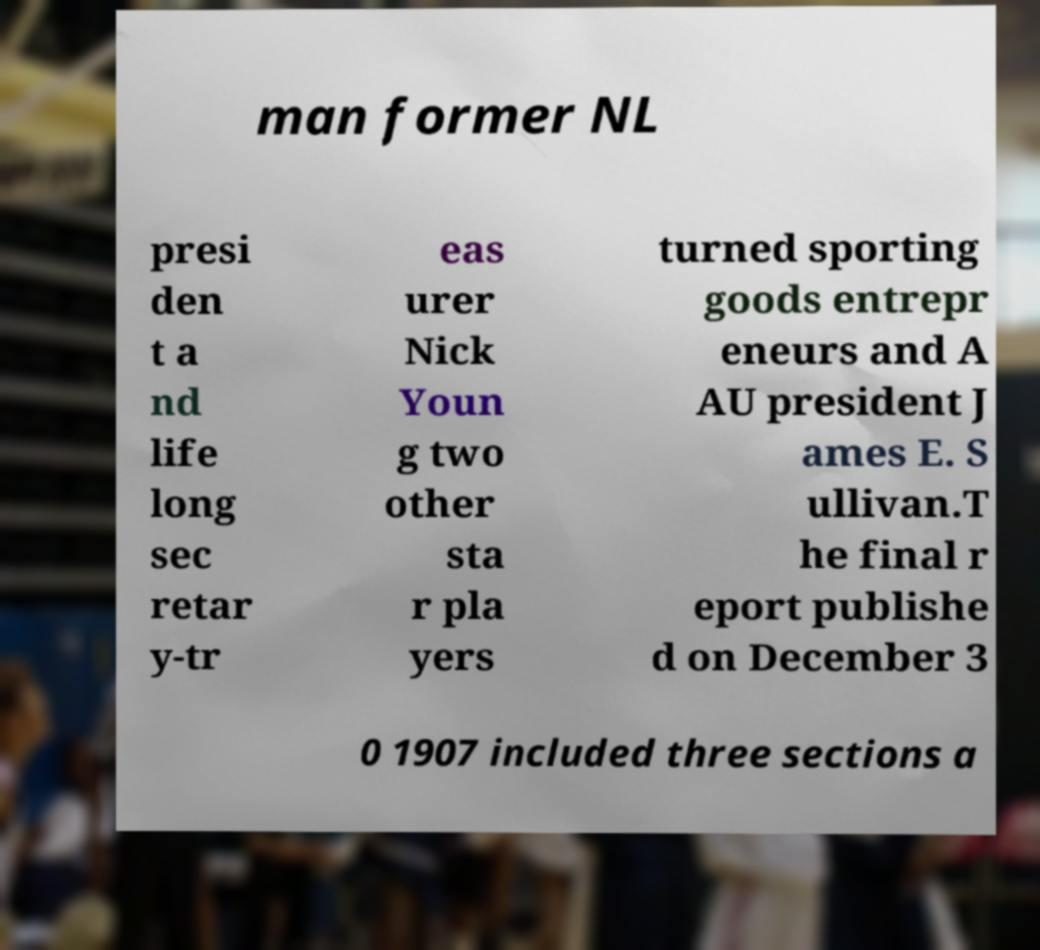Please read and relay the text visible in this image. What does it say? man former NL presi den t a nd life long sec retar y-tr eas urer Nick Youn g two other sta r pla yers turned sporting goods entrepr eneurs and A AU president J ames E. S ullivan.T he final r eport publishe d on December 3 0 1907 included three sections a 